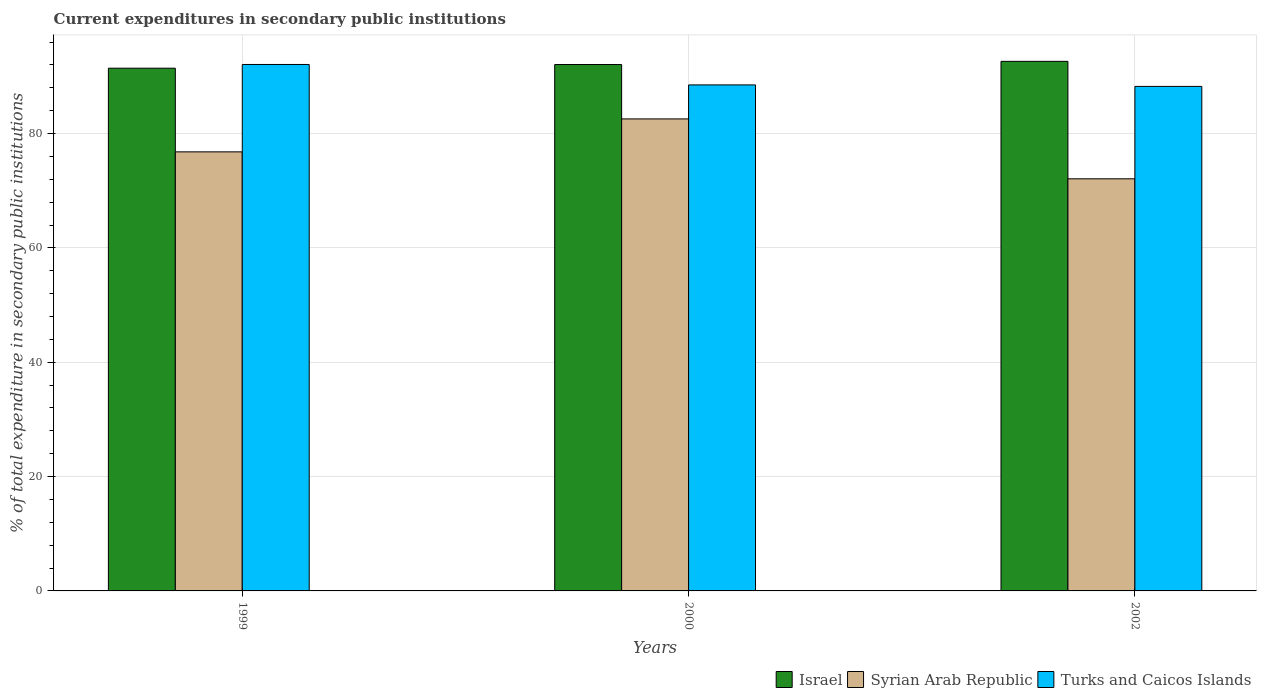Are the number of bars per tick equal to the number of legend labels?
Keep it short and to the point. Yes. How many bars are there on the 3rd tick from the right?
Offer a terse response. 3. What is the current expenditures in secondary public institutions in Israel in 2000?
Your answer should be very brief. 92.07. Across all years, what is the maximum current expenditures in secondary public institutions in Syrian Arab Republic?
Make the answer very short. 82.56. Across all years, what is the minimum current expenditures in secondary public institutions in Turks and Caicos Islands?
Your answer should be very brief. 88.24. In which year was the current expenditures in secondary public institutions in Israel maximum?
Your answer should be compact. 2002. In which year was the current expenditures in secondary public institutions in Israel minimum?
Your response must be concise. 1999. What is the total current expenditures in secondary public institutions in Israel in the graph?
Your answer should be very brief. 276.12. What is the difference between the current expenditures in secondary public institutions in Israel in 2000 and that in 2002?
Keep it short and to the point. -0.55. What is the difference between the current expenditures in secondary public institutions in Syrian Arab Republic in 2000 and the current expenditures in secondary public institutions in Turks and Caicos Islands in 2002?
Make the answer very short. -5.69. What is the average current expenditures in secondary public institutions in Israel per year?
Offer a terse response. 92.04. In the year 1999, what is the difference between the current expenditures in secondary public institutions in Israel and current expenditures in secondary public institutions in Turks and Caicos Islands?
Ensure brevity in your answer.  -0.65. What is the ratio of the current expenditures in secondary public institutions in Israel in 1999 to that in 2000?
Your answer should be compact. 0.99. Is the current expenditures in secondary public institutions in Syrian Arab Republic in 2000 less than that in 2002?
Your answer should be compact. No. What is the difference between the highest and the second highest current expenditures in secondary public institutions in Turks and Caicos Islands?
Your response must be concise. 3.57. What is the difference between the highest and the lowest current expenditures in secondary public institutions in Turks and Caicos Islands?
Provide a short and direct response. 3.83. In how many years, is the current expenditures in secondary public institutions in Turks and Caicos Islands greater than the average current expenditures in secondary public institutions in Turks and Caicos Islands taken over all years?
Give a very brief answer. 1. What does the 2nd bar from the left in 2002 represents?
Your answer should be very brief. Syrian Arab Republic. What does the 2nd bar from the right in 2000 represents?
Provide a succinct answer. Syrian Arab Republic. How many bars are there?
Ensure brevity in your answer.  9. Are the values on the major ticks of Y-axis written in scientific E-notation?
Offer a terse response. No. Does the graph contain any zero values?
Give a very brief answer. No. Where does the legend appear in the graph?
Keep it short and to the point. Bottom right. How are the legend labels stacked?
Provide a short and direct response. Horizontal. What is the title of the graph?
Your answer should be compact. Current expenditures in secondary public institutions. Does "New Zealand" appear as one of the legend labels in the graph?
Ensure brevity in your answer.  No. What is the label or title of the Y-axis?
Provide a succinct answer. % of total expenditure in secondary public institutions. What is the % of total expenditure in secondary public institutions in Israel in 1999?
Your answer should be very brief. 91.43. What is the % of total expenditure in secondary public institutions of Syrian Arab Republic in 1999?
Give a very brief answer. 76.79. What is the % of total expenditure in secondary public institutions of Turks and Caicos Islands in 1999?
Make the answer very short. 92.08. What is the % of total expenditure in secondary public institutions of Israel in 2000?
Ensure brevity in your answer.  92.07. What is the % of total expenditure in secondary public institutions in Syrian Arab Republic in 2000?
Your answer should be very brief. 82.56. What is the % of total expenditure in secondary public institutions in Turks and Caicos Islands in 2000?
Keep it short and to the point. 88.5. What is the % of total expenditure in secondary public institutions in Israel in 2002?
Keep it short and to the point. 92.62. What is the % of total expenditure in secondary public institutions of Syrian Arab Republic in 2002?
Make the answer very short. 72.08. What is the % of total expenditure in secondary public institutions in Turks and Caicos Islands in 2002?
Ensure brevity in your answer.  88.24. Across all years, what is the maximum % of total expenditure in secondary public institutions of Israel?
Keep it short and to the point. 92.62. Across all years, what is the maximum % of total expenditure in secondary public institutions of Syrian Arab Republic?
Your answer should be very brief. 82.56. Across all years, what is the maximum % of total expenditure in secondary public institutions in Turks and Caicos Islands?
Your answer should be very brief. 92.08. Across all years, what is the minimum % of total expenditure in secondary public institutions in Israel?
Make the answer very short. 91.43. Across all years, what is the minimum % of total expenditure in secondary public institutions in Syrian Arab Republic?
Offer a very short reply. 72.08. Across all years, what is the minimum % of total expenditure in secondary public institutions of Turks and Caicos Islands?
Your answer should be very brief. 88.24. What is the total % of total expenditure in secondary public institutions in Israel in the graph?
Your answer should be compact. 276.12. What is the total % of total expenditure in secondary public institutions of Syrian Arab Republic in the graph?
Provide a succinct answer. 231.43. What is the total % of total expenditure in secondary public institutions in Turks and Caicos Islands in the graph?
Your answer should be compact. 268.82. What is the difference between the % of total expenditure in secondary public institutions of Israel in 1999 and that in 2000?
Keep it short and to the point. -0.64. What is the difference between the % of total expenditure in secondary public institutions in Syrian Arab Republic in 1999 and that in 2000?
Provide a short and direct response. -5.76. What is the difference between the % of total expenditure in secondary public institutions of Turks and Caicos Islands in 1999 and that in 2000?
Provide a short and direct response. 3.57. What is the difference between the % of total expenditure in secondary public institutions of Israel in 1999 and that in 2002?
Your answer should be compact. -1.2. What is the difference between the % of total expenditure in secondary public institutions of Syrian Arab Republic in 1999 and that in 2002?
Keep it short and to the point. 4.71. What is the difference between the % of total expenditure in secondary public institutions in Turks and Caicos Islands in 1999 and that in 2002?
Give a very brief answer. 3.83. What is the difference between the % of total expenditure in secondary public institutions of Israel in 2000 and that in 2002?
Your response must be concise. -0.55. What is the difference between the % of total expenditure in secondary public institutions of Syrian Arab Republic in 2000 and that in 2002?
Keep it short and to the point. 10.48. What is the difference between the % of total expenditure in secondary public institutions in Turks and Caicos Islands in 2000 and that in 2002?
Ensure brevity in your answer.  0.26. What is the difference between the % of total expenditure in secondary public institutions of Israel in 1999 and the % of total expenditure in secondary public institutions of Syrian Arab Republic in 2000?
Keep it short and to the point. 8.87. What is the difference between the % of total expenditure in secondary public institutions in Israel in 1999 and the % of total expenditure in secondary public institutions in Turks and Caicos Islands in 2000?
Offer a very short reply. 2.93. What is the difference between the % of total expenditure in secondary public institutions of Syrian Arab Republic in 1999 and the % of total expenditure in secondary public institutions of Turks and Caicos Islands in 2000?
Offer a very short reply. -11.71. What is the difference between the % of total expenditure in secondary public institutions of Israel in 1999 and the % of total expenditure in secondary public institutions of Syrian Arab Republic in 2002?
Provide a short and direct response. 19.35. What is the difference between the % of total expenditure in secondary public institutions in Israel in 1999 and the % of total expenditure in secondary public institutions in Turks and Caicos Islands in 2002?
Your answer should be very brief. 3.19. What is the difference between the % of total expenditure in secondary public institutions in Syrian Arab Republic in 1999 and the % of total expenditure in secondary public institutions in Turks and Caicos Islands in 2002?
Ensure brevity in your answer.  -11.45. What is the difference between the % of total expenditure in secondary public institutions of Israel in 2000 and the % of total expenditure in secondary public institutions of Syrian Arab Republic in 2002?
Your response must be concise. 19.99. What is the difference between the % of total expenditure in secondary public institutions of Israel in 2000 and the % of total expenditure in secondary public institutions of Turks and Caicos Islands in 2002?
Make the answer very short. 3.83. What is the difference between the % of total expenditure in secondary public institutions of Syrian Arab Republic in 2000 and the % of total expenditure in secondary public institutions of Turks and Caicos Islands in 2002?
Your answer should be compact. -5.69. What is the average % of total expenditure in secondary public institutions in Israel per year?
Offer a terse response. 92.04. What is the average % of total expenditure in secondary public institutions of Syrian Arab Republic per year?
Ensure brevity in your answer.  77.14. What is the average % of total expenditure in secondary public institutions in Turks and Caicos Islands per year?
Provide a short and direct response. 89.61. In the year 1999, what is the difference between the % of total expenditure in secondary public institutions of Israel and % of total expenditure in secondary public institutions of Syrian Arab Republic?
Your answer should be compact. 14.63. In the year 1999, what is the difference between the % of total expenditure in secondary public institutions of Israel and % of total expenditure in secondary public institutions of Turks and Caicos Islands?
Provide a short and direct response. -0.65. In the year 1999, what is the difference between the % of total expenditure in secondary public institutions of Syrian Arab Republic and % of total expenditure in secondary public institutions of Turks and Caicos Islands?
Give a very brief answer. -15.28. In the year 2000, what is the difference between the % of total expenditure in secondary public institutions of Israel and % of total expenditure in secondary public institutions of Syrian Arab Republic?
Ensure brevity in your answer.  9.51. In the year 2000, what is the difference between the % of total expenditure in secondary public institutions of Israel and % of total expenditure in secondary public institutions of Turks and Caicos Islands?
Ensure brevity in your answer.  3.57. In the year 2000, what is the difference between the % of total expenditure in secondary public institutions of Syrian Arab Republic and % of total expenditure in secondary public institutions of Turks and Caicos Islands?
Provide a succinct answer. -5.95. In the year 2002, what is the difference between the % of total expenditure in secondary public institutions in Israel and % of total expenditure in secondary public institutions in Syrian Arab Republic?
Give a very brief answer. 20.54. In the year 2002, what is the difference between the % of total expenditure in secondary public institutions of Israel and % of total expenditure in secondary public institutions of Turks and Caicos Islands?
Your response must be concise. 4.38. In the year 2002, what is the difference between the % of total expenditure in secondary public institutions of Syrian Arab Republic and % of total expenditure in secondary public institutions of Turks and Caicos Islands?
Keep it short and to the point. -16.16. What is the ratio of the % of total expenditure in secondary public institutions of Israel in 1999 to that in 2000?
Make the answer very short. 0.99. What is the ratio of the % of total expenditure in secondary public institutions of Syrian Arab Republic in 1999 to that in 2000?
Give a very brief answer. 0.93. What is the ratio of the % of total expenditure in secondary public institutions in Turks and Caicos Islands in 1999 to that in 2000?
Offer a terse response. 1.04. What is the ratio of the % of total expenditure in secondary public institutions in Israel in 1999 to that in 2002?
Your answer should be compact. 0.99. What is the ratio of the % of total expenditure in secondary public institutions of Syrian Arab Republic in 1999 to that in 2002?
Give a very brief answer. 1.07. What is the ratio of the % of total expenditure in secondary public institutions in Turks and Caicos Islands in 1999 to that in 2002?
Offer a very short reply. 1.04. What is the ratio of the % of total expenditure in secondary public institutions of Syrian Arab Republic in 2000 to that in 2002?
Offer a very short reply. 1.15. What is the difference between the highest and the second highest % of total expenditure in secondary public institutions in Israel?
Keep it short and to the point. 0.55. What is the difference between the highest and the second highest % of total expenditure in secondary public institutions in Syrian Arab Republic?
Provide a short and direct response. 5.76. What is the difference between the highest and the second highest % of total expenditure in secondary public institutions in Turks and Caicos Islands?
Provide a short and direct response. 3.57. What is the difference between the highest and the lowest % of total expenditure in secondary public institutions of Israel?
Your response must be concise. 1.2. What is the difference between the highest and the lowest % of total expenditure in secondary public institutions in Syrian Arab Republic?
Your response must be concise. 10.48. What is the difference between the highest and the lowest % of total expenditure in secondary public institutions in Turks and Caicos Islands?
Offer a very short reply. 3.83. 